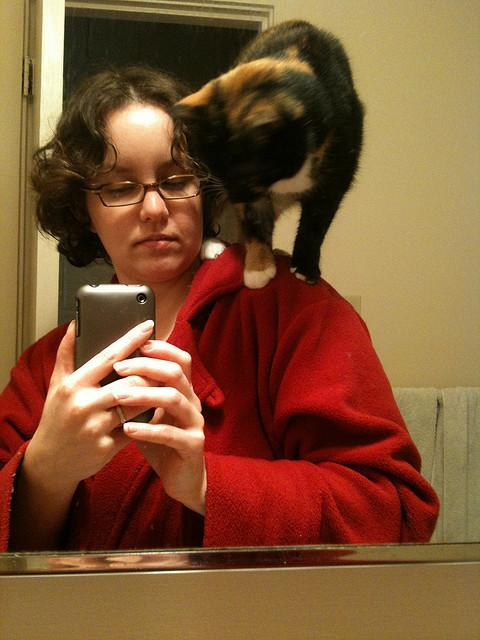What bathroom fixture is located in front of the woman at waist height? towel rack 